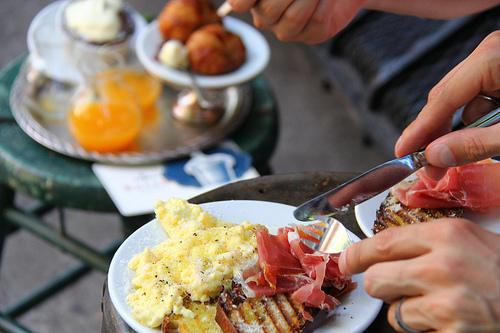Question: what color are the utensils?
Choices:
A. Silver.
B. White.
C. Pink.
D. Gold.
Answer with the letter. Answer: A Question: what two utensils are shown?
Choices:
A. Fork and spoon.
B. Spoon and knife.
C. Chopsticks.
D. Knife and fork.
Answer with the letter. Answer: D Question: what is the color of the juice?
Choices:
A. Orange.
B. Green.
C. Red.
D. Yellow.
Answer with the letter. Answer: A Question: where was the picture taken?
Choices:
A. An indoor cafe.
B. An outdoor cafe.
C. A field.
D. A warehouse.
Answer with the letter. Answer: B 